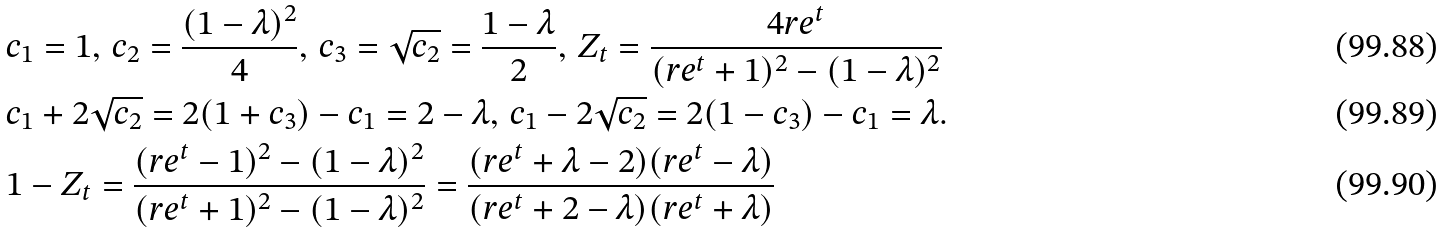<formula> <loc_0><loc_0><loc_500><loc_500>& c _ { 1 } = 1 , \, c _ { 2 } = \frac { ( 1 - \lambda ) ^ { 2 } } { 4 } , \, c _ { 3 } = \sqrt { c _ { 2 } } = \frac { 1 - \lambda } { 2 } , \, Z _ { t } = \frac { 4 r e ^ { t } } { ( r e ^ { t } + 1 ) ^ { 2 } - ( 1 - \lambda ) ^ { 2 } } \\ & c _ { 1 } + 2 \sqrt { c _ { 2 } } = 2 ( 1 + c _ { 3 } ) - c _ { 1 } = 2 - \lambda , \, c _ { 1 } - 2 \sqrt { c _ { 2 } } = 2 ( 1 - c _ { 3 } ) - c _ { 1 } = \lambda . \\ & 1 - Z _ { t } = \frac { ( r e ^ { t } - 1 ) ^ { 2 } - ( 1 - \lambda ) ^ { 2 } } { ( r e ^ { t } + 1 ) ^ { 2 } - ( 1 - \lambda ) ^ { 2 } } = \frac { ( r e ^ { t } + \lambda - 2 ) ( r e ^ { t } - \lambda ) } { ( r e ^ { t } + 2 - \lambda ) ( r e ^ { t } + \lambda ) }</formula> 